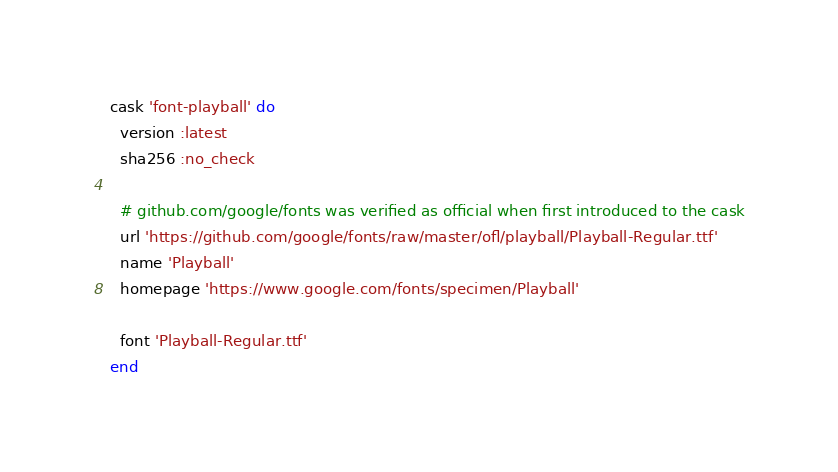Convert code to text. <code><loc_0><loc_0><loc_500><loc_500><_Ruby_>cask 'font-playball' do
  version :latest
  sha256 :no_check

  # github.com/google/fonts was verified as official when first introduced to the cask
  url 'https://github.com/google/fonts/raw/master/ofl/playball/Playball-Regular.ttf'
  name 'Playball'
  homepage 'https://www.google.com/fonts/specimen/Playball'

  font 'Playball-Regular.ttf'
end
</code> 